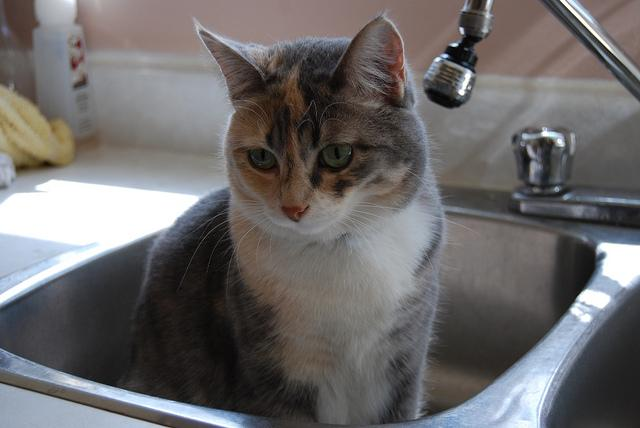What material is the sink made of? stainless steel 